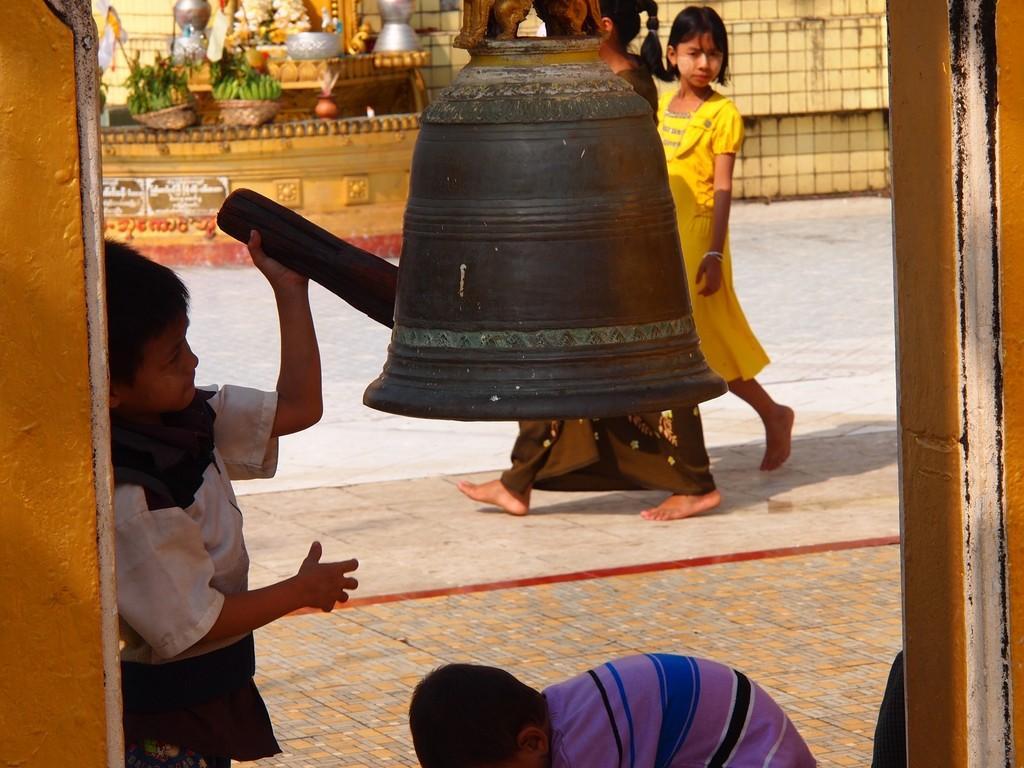Could you give a brief overview of what you see in this image? This image consists of a boy ringing the bell. At the bottom, there is a floor. In the background, there are people walking. To the left, there is a wall. 